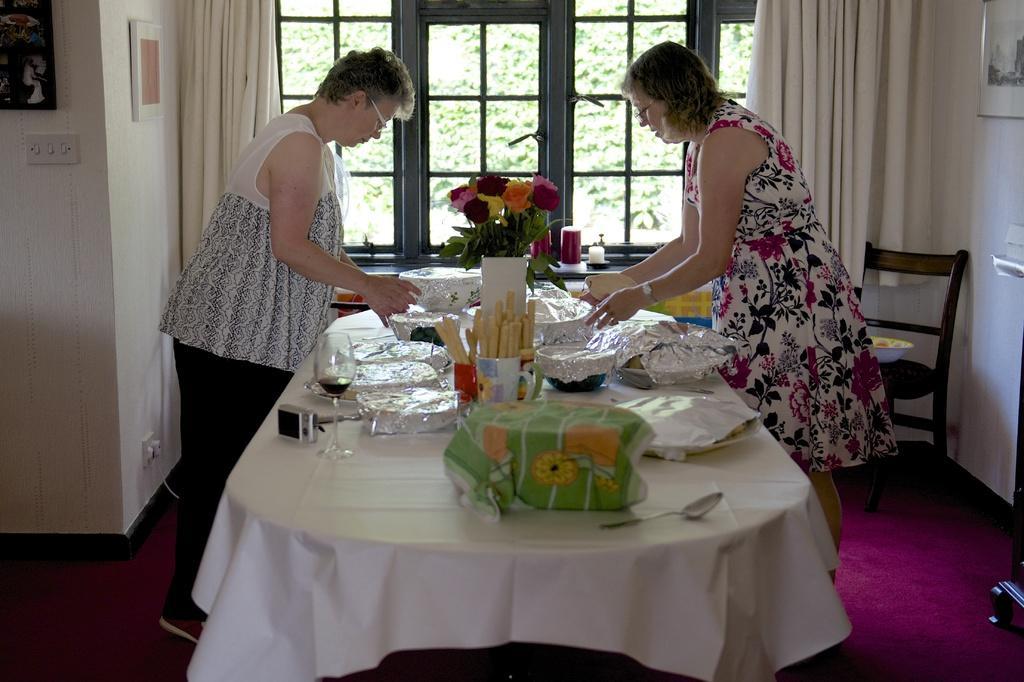In one or two sentences, can you explain what this image depicts? As we can see in the image there is a window, curtains, white color wall and photo frames and there is a table over here. On table there are glasses and plates and there are two women standing on floor. 